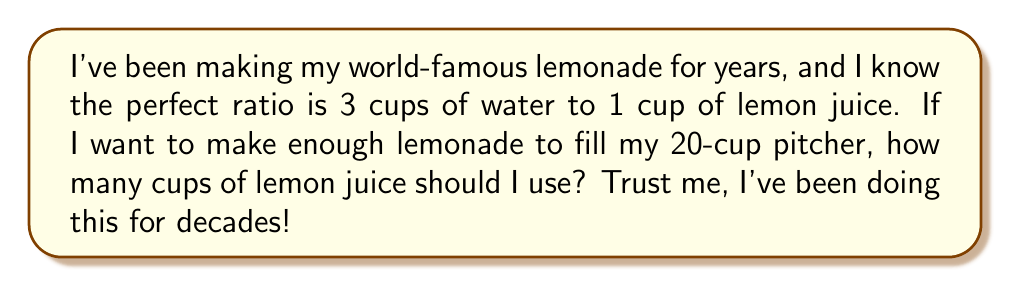What is the answer to this math problem? Let's break this down step-by-step:

1) First, we need to understand the given ratio:
   $3$ cups of water : $1$ cup of lemon juice

2) This means for every $4$ cups of lemonade ($3$ water + $1$ lemon juice), we use $1$ cup of lemon juice.

3) We can set up a proportion:
   $$\frac{1\text{ cup lemon juice}}{4\text{ cups lemonade}} = \frac{x\text{ cups lemon juice}}{20\text{ cups lemonade}}$$

4) Cross multiply:
   $$1 \cdot 20 = 4x$$

5) Solve for $x$:
   $$20 = 4x$$
   $$x = 5$$

Therefore, we need $5$ cups of lemon juice to make $20$ cups of lemonade.
Answer: $5$ cups 